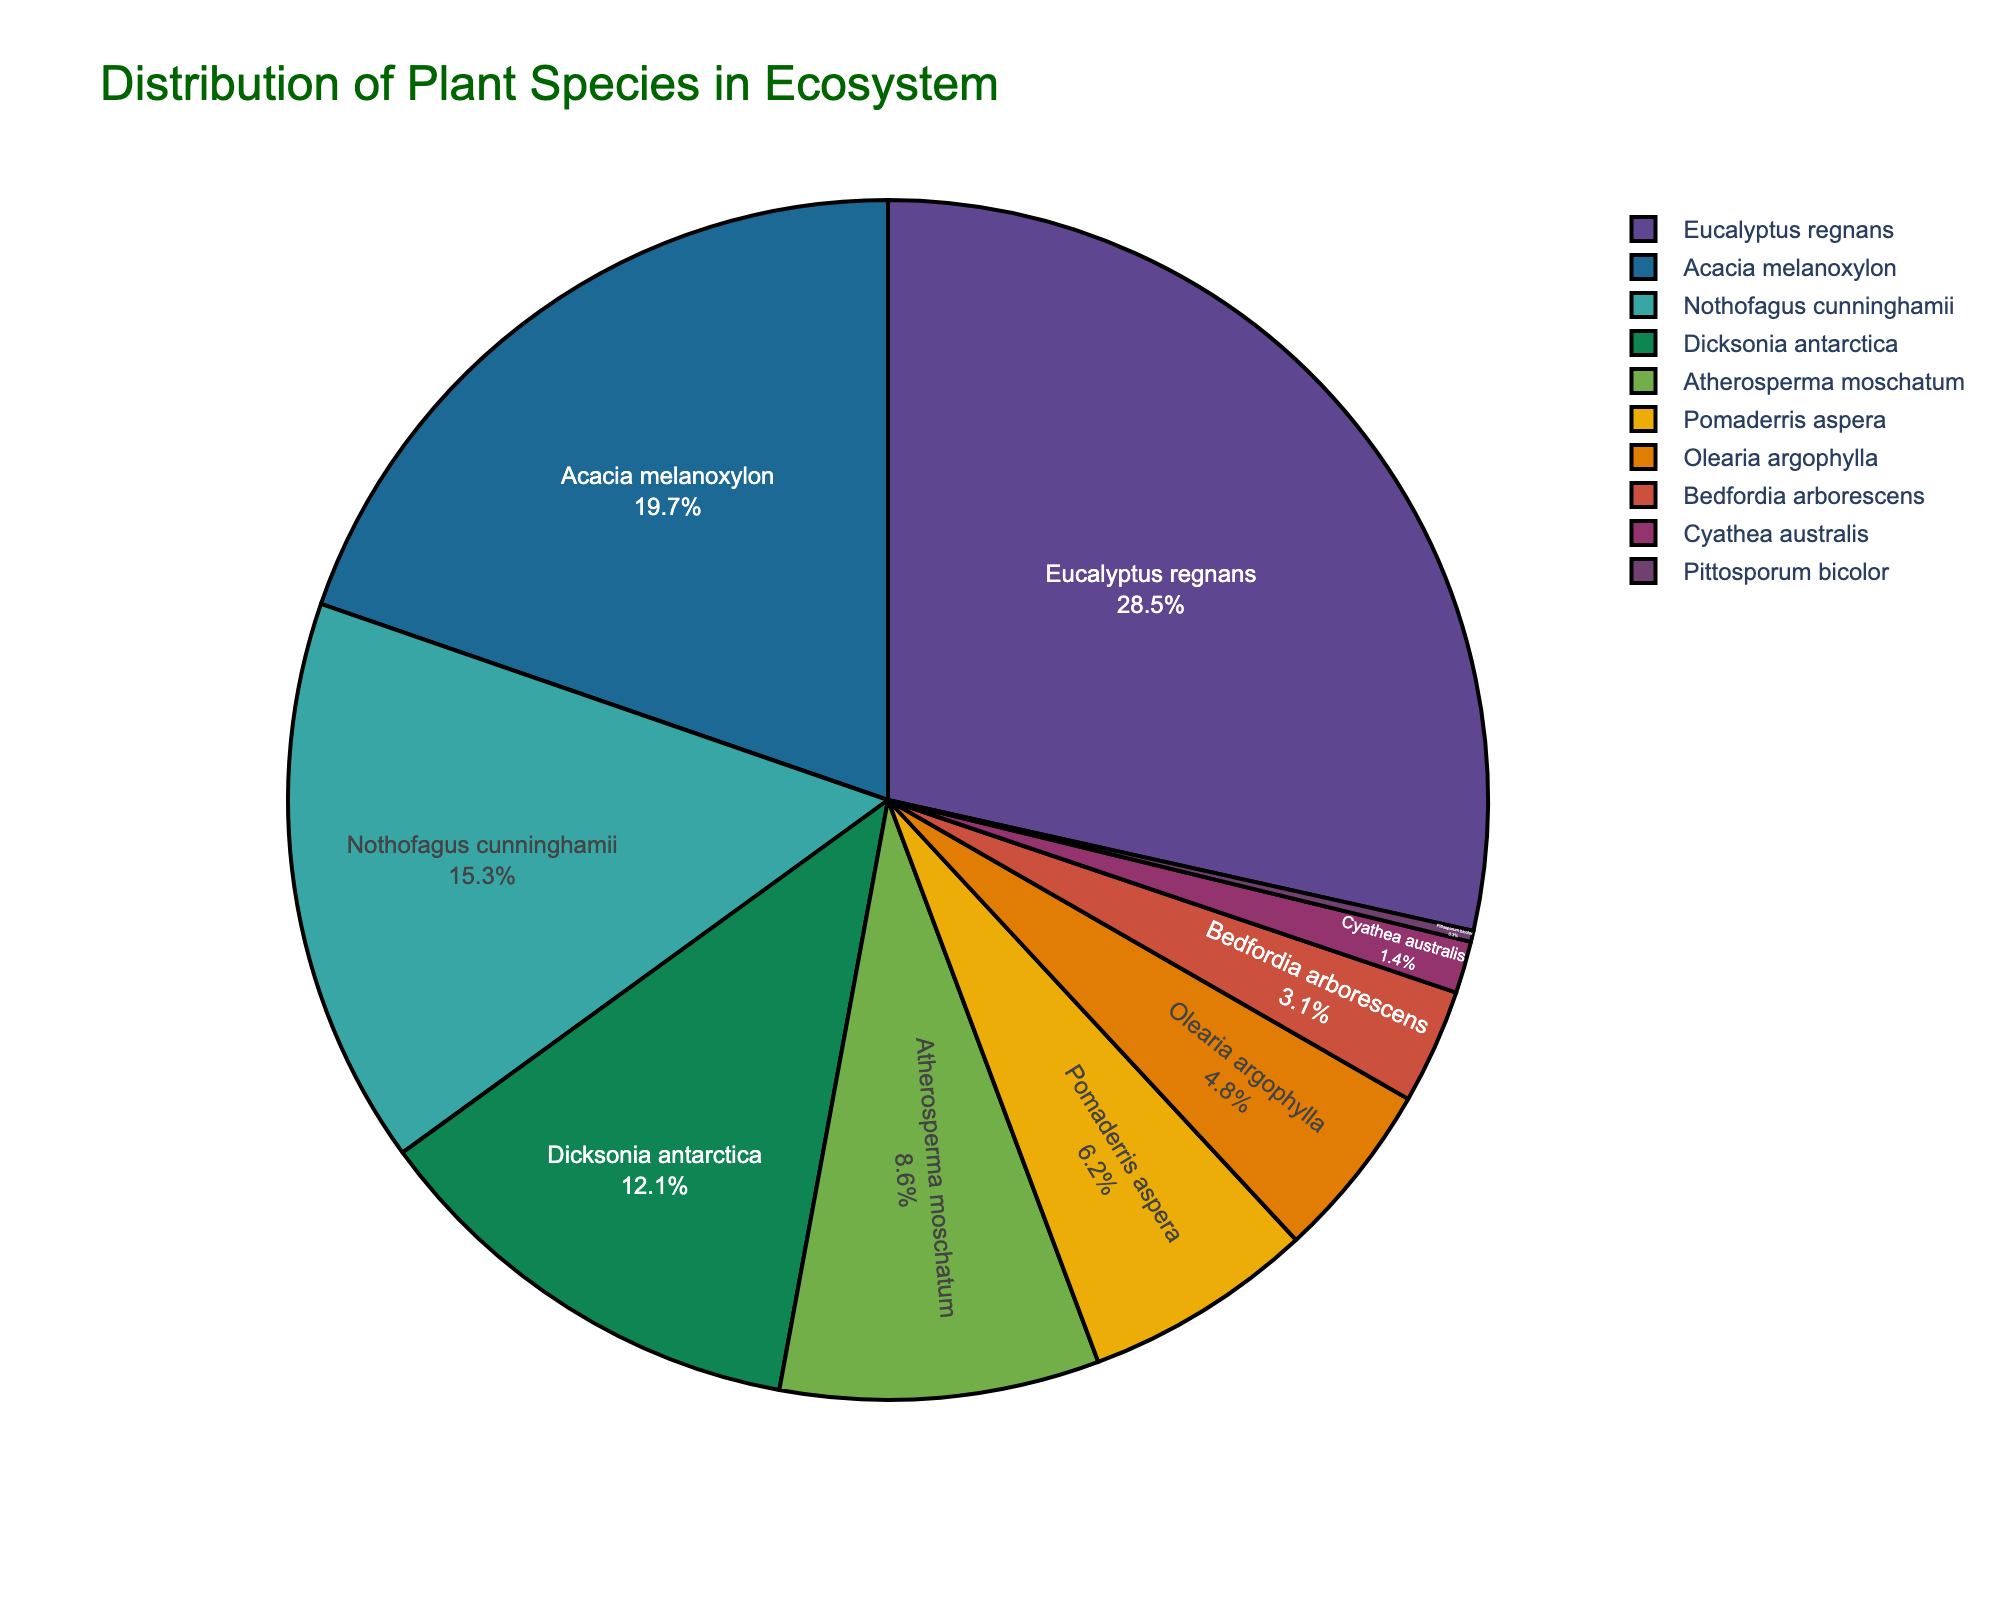What is the species with the highest percentage in the ecosystem? By looking at the pie chart, we can identify the section with the highest percentage by its size. The largest section corresponds to the Eucalyptus regnans with 28.5%.
Answer: Eucalyptus regnans Which species has the smallest representation in the ecosystem? By examining the relative sizes of the sections, the smallest section represents Pittosporum bicolor, contributing 0.3% to the ecosystem.
Answer: Pittosporum bicolor What are the combined percentages of Nothofagus cunninghamii and Acacia melanoxylon? Sum the percentages of Nothofagus cunninghamii (15.3%) and Acacia melanoxylon (19.7%): 15.3% + 19.7% = 35.0%.
Answer: 35.0% Which species occupy less than 5% of the ecosystem? Observing the chart for sections smaller than 5%, we find Olearia argophylla (4.8%), Bedfordia arborescens (3.1%), Cyathea australis (1.4%), and Pittosporum bicolor (0.3%).
Answer: Olearia argophylla, Bedfordia arborescens, Cyathea australis, Pittosporum bicolor What is the visual appearance of the section representing Acacia melanoxylon? The section for Acacia melanoxylon can be identified on the pie chart by locating the color and text label. It's colored in line with the palette used and occupies a significant portion of the chart.
Answer: A large section with a corresponding color in the palette, labeled "Acacia melanoxylon" Which species contribute more to the ecosystem than Dicksonia antarctica? Comparing the percentages, Eucalyptus regnans (28.5%) and Acacia melanoxylon (19.7%) are greater than Dicksonia antarctica (12.1%).
Answer: Eucalyptus regnans, Acacia melanoxylon What is the difference in percentage between Eucalyptus regnans and Atherosperma moschatum? Subtract the percentage of Atherosperma moschatum (8.6%) from Eucalyptus regnans (28.5%): 28.5% - 8.6% = 19.9%.
Answer: 19.9% How is the percentage of Cyathea australis compared to that of Pomaderris aspera? Comparing the values, Pomaderris aspera has a larger percentage (6.2%) than Cyathea australis (1.4%).
Answer: Pomaderris aspera is larger If we combine the percentages of Atherosperma moschatum, Pomaderris aspera, and Bedfordia arborescens, what is the total percentage? Add the percentages of Atherosperma moschatum (8.6%), Pomaderris aspera (6.2%), and Bedfordia arborescens (3.1%): 8.6% + 6.2% + 3.1% = 17.9%.
Answer: 17.9% Which species have percentages between 10% and 20%? The species with percentages in this range are Acacia melanoxylon (19.7%) and Nothofagus cunninghamii (15.3%).
Answer: Acacia melanoxylon, Nothofagus cunninghamii 